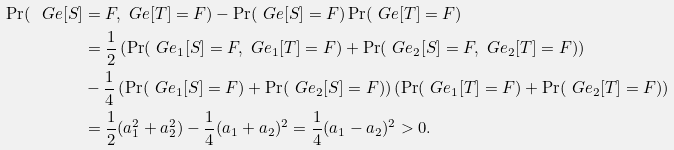<formula> <loc_0><loc_0><loc_500><loc_500>\Pr ( \ G e [ S ] & = F , \ G e [ T ] = F ) - \Pr ( \ G e [ S ] = F ) \Pr ( \ G e [ T ] = F ) \\ & = \frac { 1 } { 2 } \left ( \Pr ( \ G e _ { 1 } [ S ] = F , \ G e _ { 1 } [ T ] = F ) + \Pr ( \ G e _ { 2 } [ S ] = F , \ G e _ { 2 } [ T ] = F ) \right ) \\ & - \frac { 1 } { 4 } \left ( \Pr ( \ G e _ { 1 } [ S ] = F ) + \Pr ( \ G e _ { 2 } [ S ] = F ) \right ) \left ( \Pr ( \ G e _ { 1 } [ T ] = F ) + \Pr ( \ G e _ { 2 } [ T ] = F ) \right ) \\ & = \frac { 1 } { 2 } ( a _ { 1 } ^ { 2 } + a _ { 2 } ^ { 2 } ) - \frac { 1 } { 4 } ( a _ { 1 } + a _ { 2 } ) ^ { 2 } = \frac { 1 } { 4 } ( a _ { 1 } - a _ { 2 } ) ^ { 2 } > 0 .</formula> 